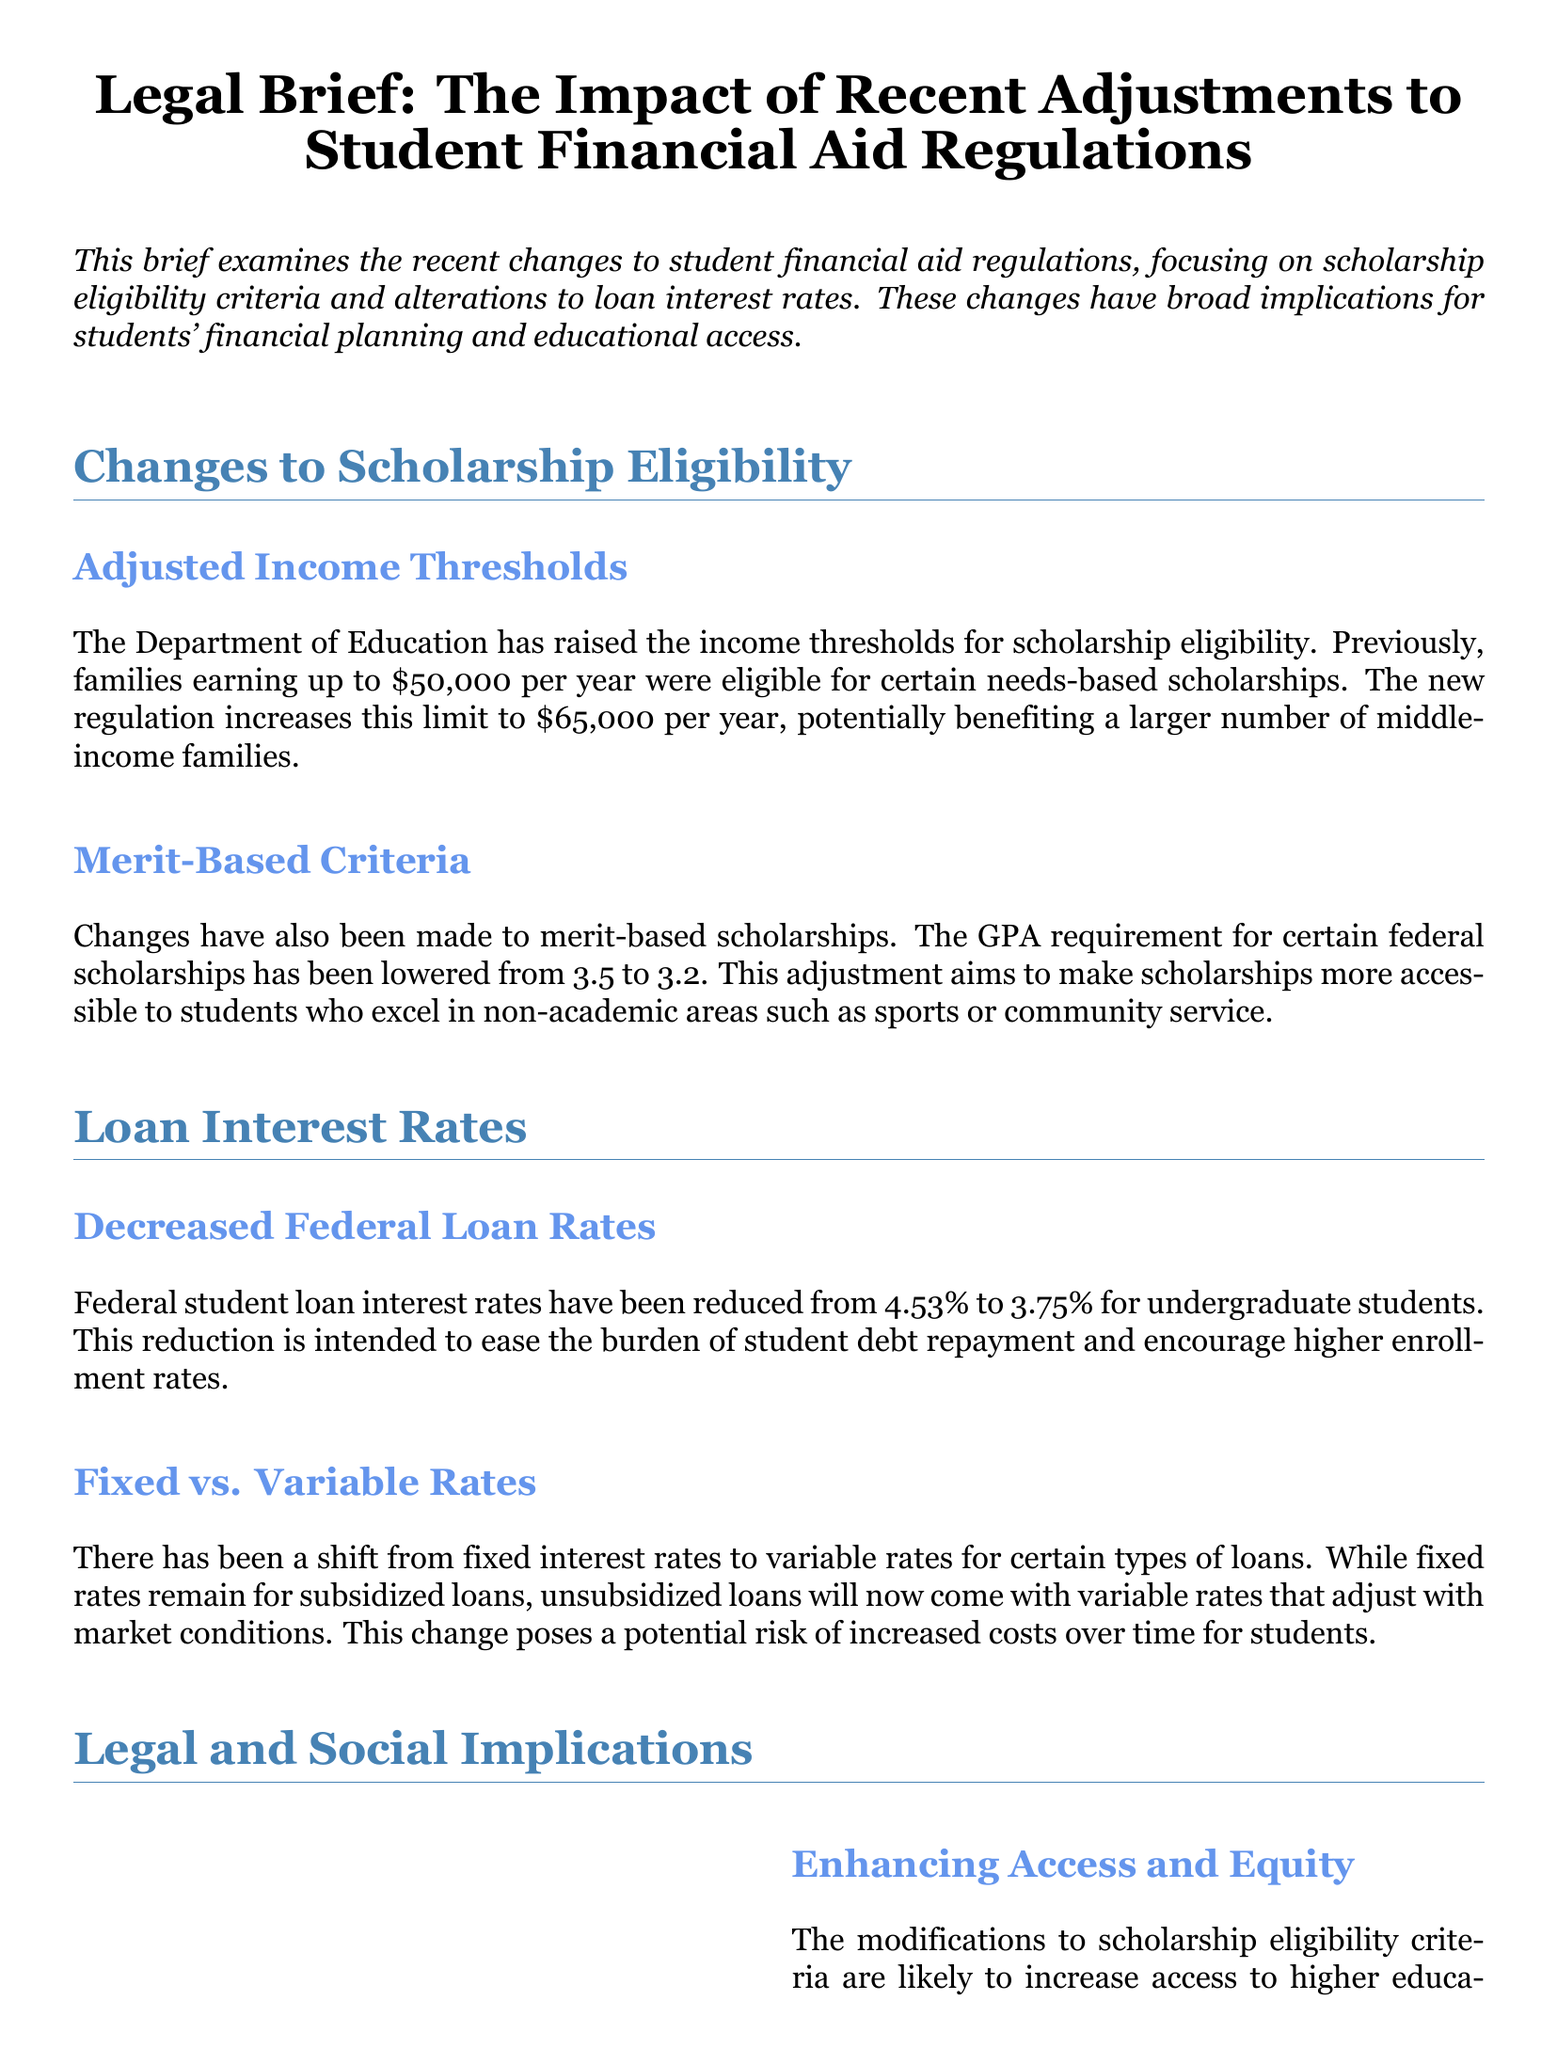What are the new income thresholds for scholarship eligibility? The document states that the new regulation increases the income threshold for scholarship eligibility to $65,000 per year.
Answer: $65,000 What was the previous GPA requirement for federal scholarships? The previous GPA requirement for certain federal scholarships was 3.5.
Answer: 3.5 What is the new federal student loan interest rate for undergraduate students? The document indicates that the new federal student loan interest rate for undergraduate students has been reduced to 3.75%.
Answer: 3.75% What type of rates are now applied to unsubsidized loans? The document mentions that unsubsidized loans will now come with variable rates that adjust with market conditions.
Answer: Variable rates What impact do the changes have on students from diverse socioeconomic backgrounds? The modification to scholarship eligibility criteria is likely to increase access to higher education for students from diverse socioeconomic backgrounds.
Answer: Increase access What financial risk might students face with variable interest rates? The document suggests that students could face increased costs over time if variable rates rise.
Answer: Increased costs What is the primary goal of the recent changes to loan interest rates? The document highlights that the reduction in loan interest rates is intended to ease the burden of student debt repayment.
Answer: Ease burden How do the recent adjustments to student financial aid regulations relate to educational access? The changes to scholarship eligibility criteria are likely to improve educational access for students.
Answer: Improve access 